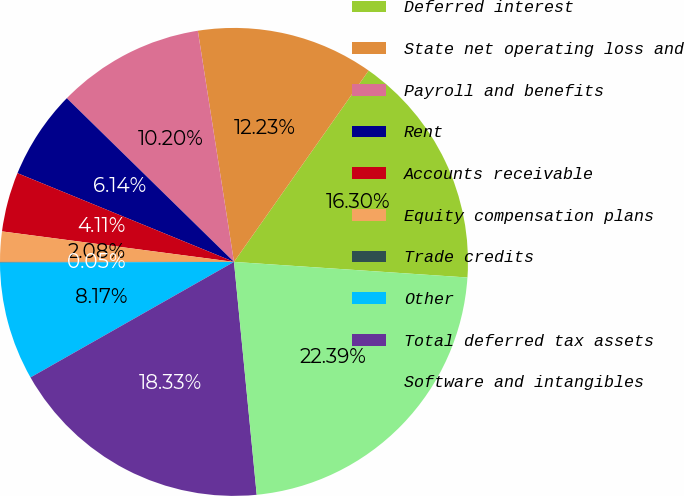Convert chart. <chart><loc_0><loc_0><loc_500><loc_500><pie_chart><fcel>Deferred interest<fcel>State net operating loss and<fcel>Payroll and benefits<fcel>Rent<fcel>Accounts receivable<fcel>Equity compensation plans<fcel>Trade credits<fcel>Other<fcel>Total deferred tax assets<fcel>Software and intangibles<nl><fcel>16.3%<fcel>12.23%<fcel>10.2%<fcel>6.14%<fcel>4.11%<fcel>2.08%<fcel>0.05%<fcel>8.17%<fcel>18.33%<fcel>22.39%<nl></chart> 